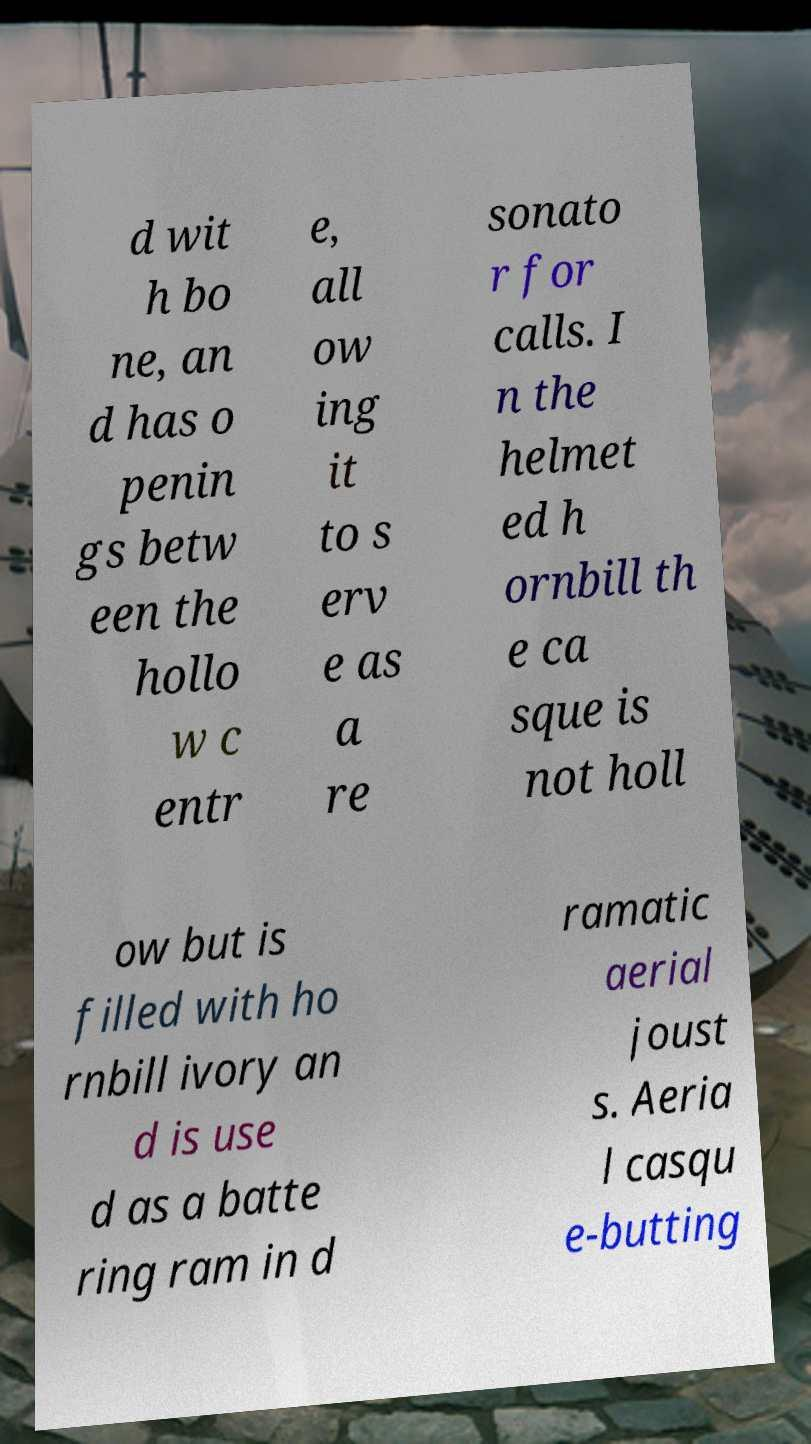Could you extract and type out the text from this image? d wit h bo ne, an d has o penin gs betw een the hollo w c entr e, all ow ing it to s erv e as a re sonato r for calls. I n the helmet ed h ornbill th e ca sque is not holl ow but is filled with ho rnbill ivory an d is use d as a batte ring ram in d ramatic aerial joust s. Aeria l casqu e-butting 